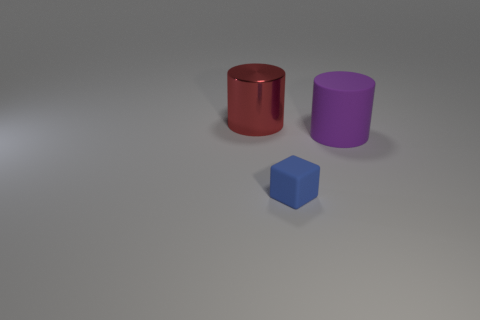Add 2 small red rubber things. How many objects exist? 5 Subtract all blocks. How many objects are left? 2 Add 3 tiny blue matte blocks. How many tiny blue matte blocks exist? 4 Subtract 0 red cubes. How many objects are left? 3 Subtract all matte blocks. Subtract all big purple objects. How many objects are left? 1 Add 2 big red metal cylinders. How many big red metal cylinders are left? 3 